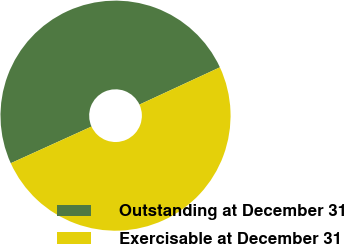Convert chart. <chart><loc_0><loc_0><loc_500><loc_500><pie_chart><fcel>Outstanding at December 31<fcel>Exercisable at December 31<nl><fcel>49.88%<fcel>50.12%<nl></chart> 